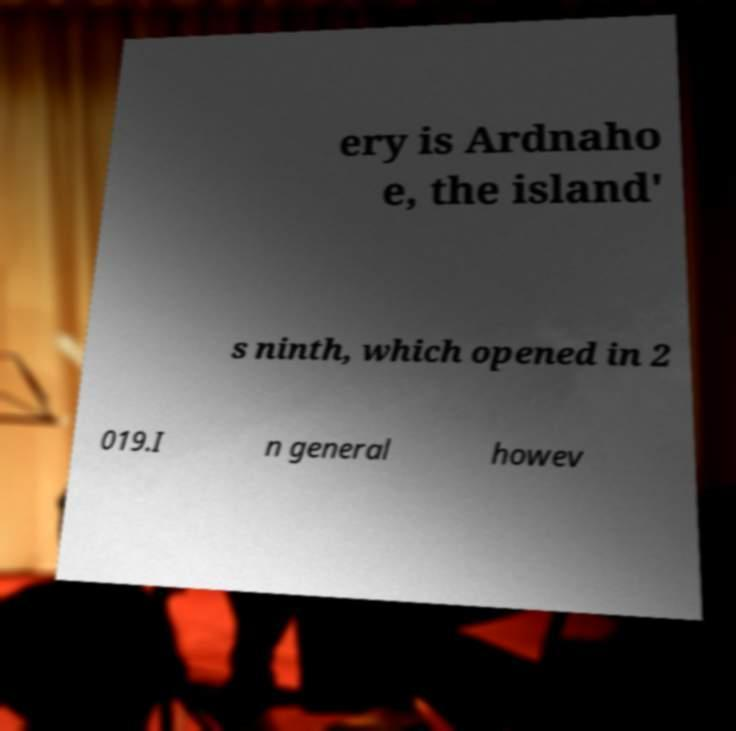Can you accurately transcribe the text from the provided image for me? ery is Ardnaho e, the island' s ninth, which opened in 2 019.I n general howev 